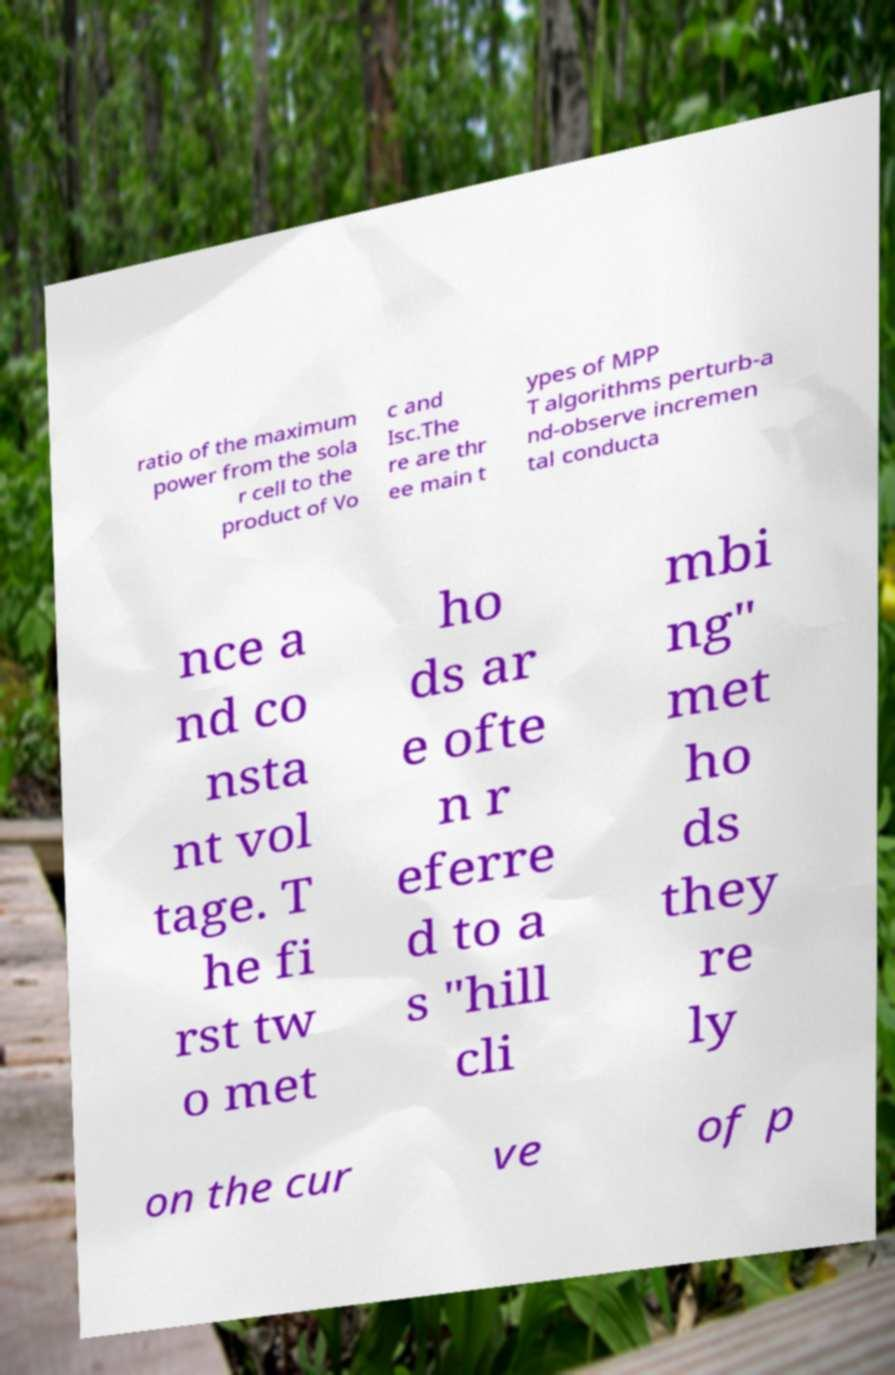For documentation purposes, I need the text within this image transcribed. Could you provide that? ratio of the maximum power from the sola r cell to the product of Vo c and Isc.The re are thr ee main t ypes of MPP T algorithms perturb-a nd-observe incremen tal conducta nce a nd co nsta nt vol tage. T he fi rst tw o met ho ds ar e ofte n r eferre d to a s "hill cli mbi ng" met ho ds they re ly on the cur ve of p 